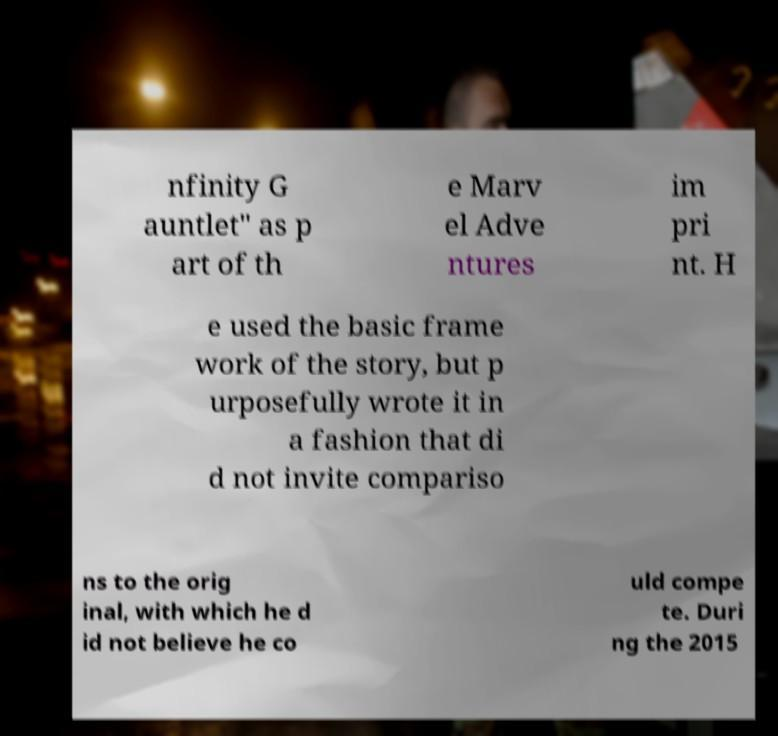Please read and relay the text visible in this image. What does it say? nfinity G auntlet" as p art of th e Marv el Adve ntures im pri nt. H e used the basic frame work of the story, but p urposefully wrote it in a fashion that di d not invite compariso ns to the orig inal, with which he d id not believe he co uld compe te. Duri ng the 2015 